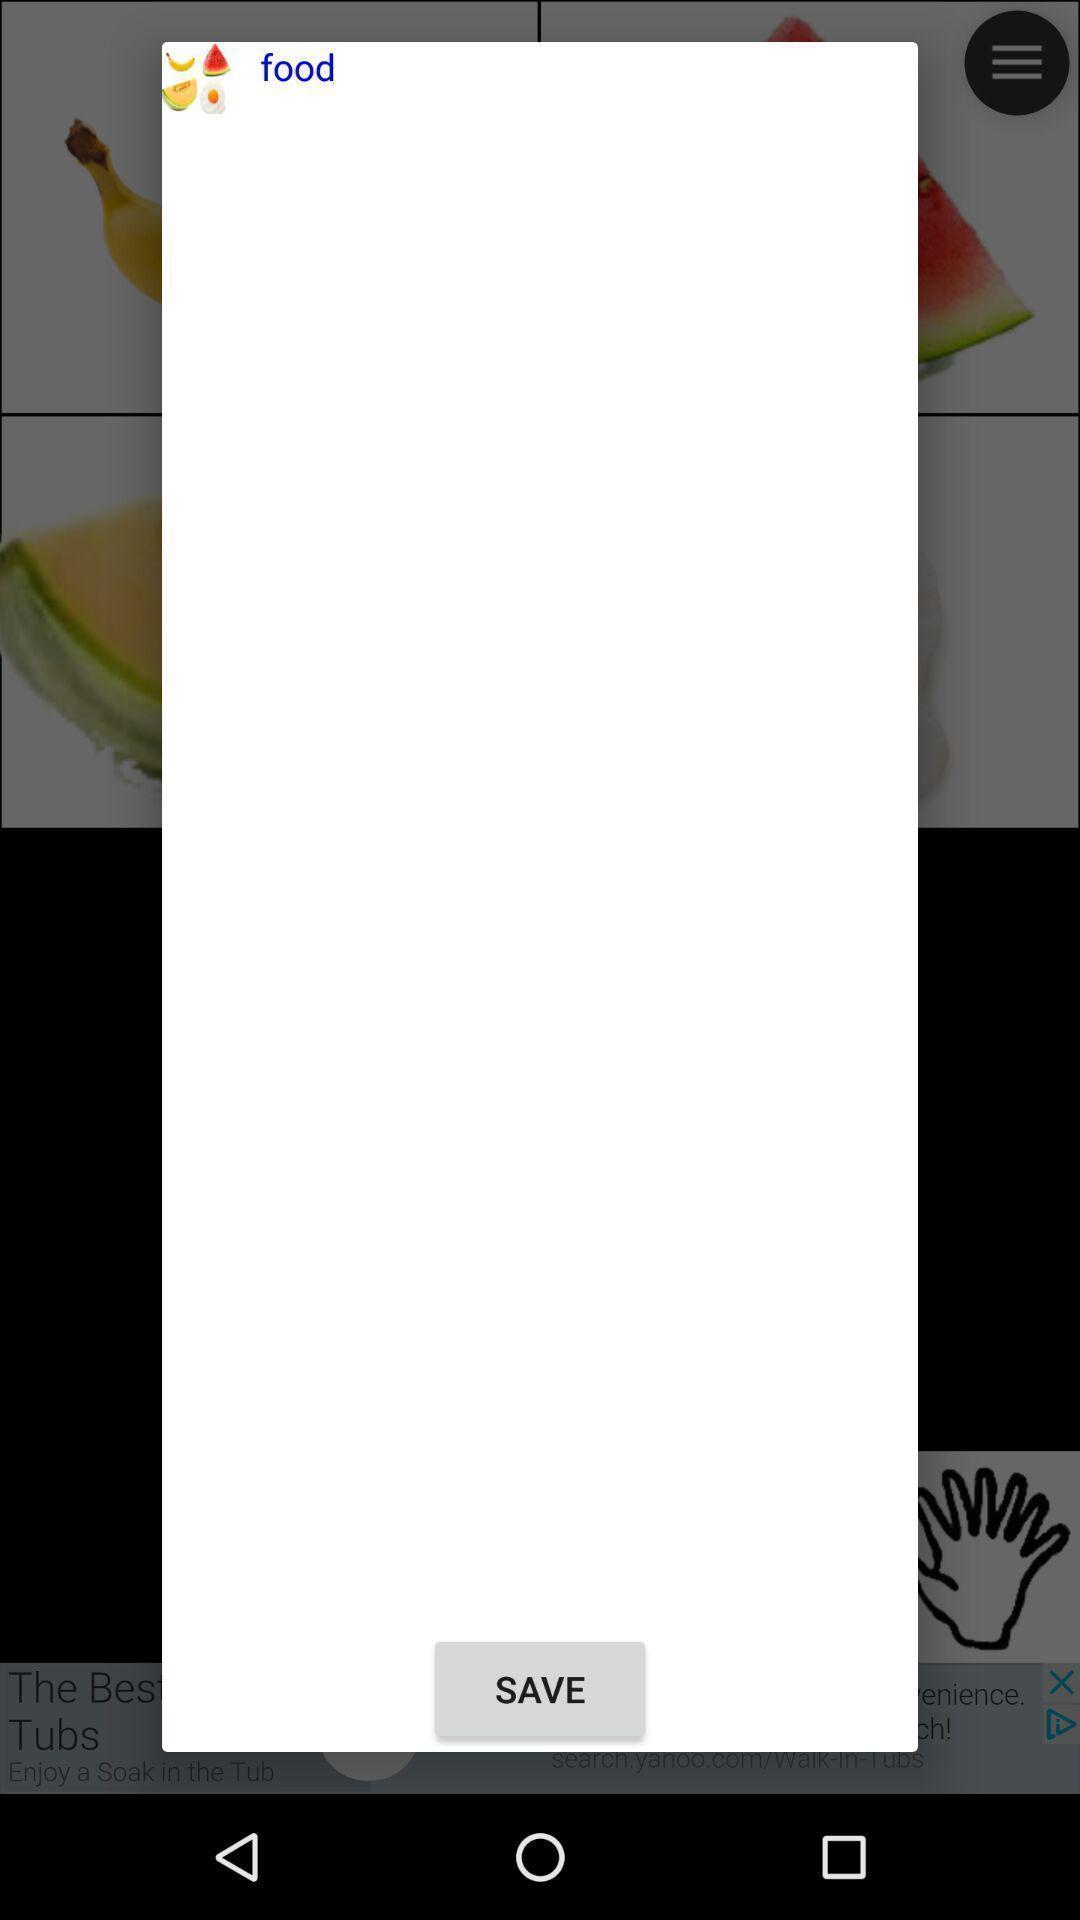What details can you identify in this image? Pop-up window showing a category to save. 